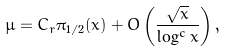<formula> <loc_0><loc_0><loc_500><loc_500>\mu = C _ { r } \pi _ { 1 / 2 } ( x ) + O \left ( \frac { \sqrt { x } } { \log ^ { c } x } \right ) ,</formula> 